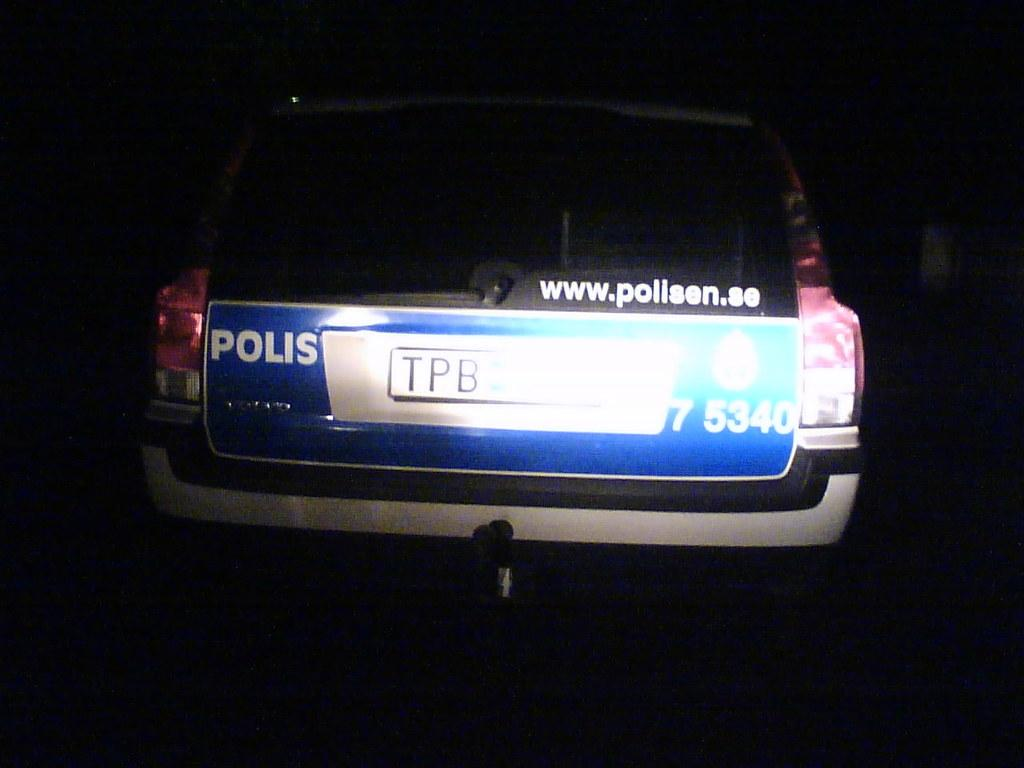What is the main subject of the image? There is a vehicle in the image. What can be seen on the vehicle? The vehicle has a number plate. What is the color of the background in the image? The background of the image is black. Did the vehicle experience any damage due to the earthquake in the image? There is no earthquake present in the image, and therefore no such damage can be observed. 